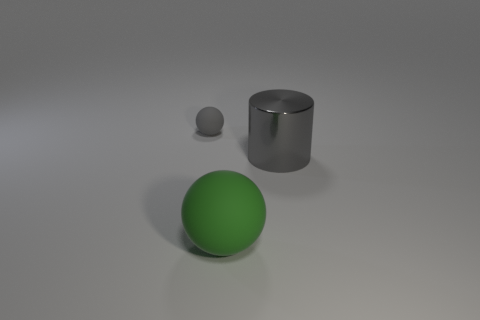Add 1 cyan cylinders. How many objects exist? 4 Subtract all green spheres. How many spheres are left? 1 Subtract 2 balls. How many balls are left? 0 Subtract 1 gray cylinders. How many objects are left? 2 Subtract all spheres. How many objects are left? 1 Subtract all brown cylinders. Subtract all purple spheres. How many cylinders are left? 1 Subtract all gray balls. Subtract all balls. How many objects are left? 0 Add 1 gray objects. How many gray objects are left? 3 Add 2 big green things. How many big green things exist? 3 